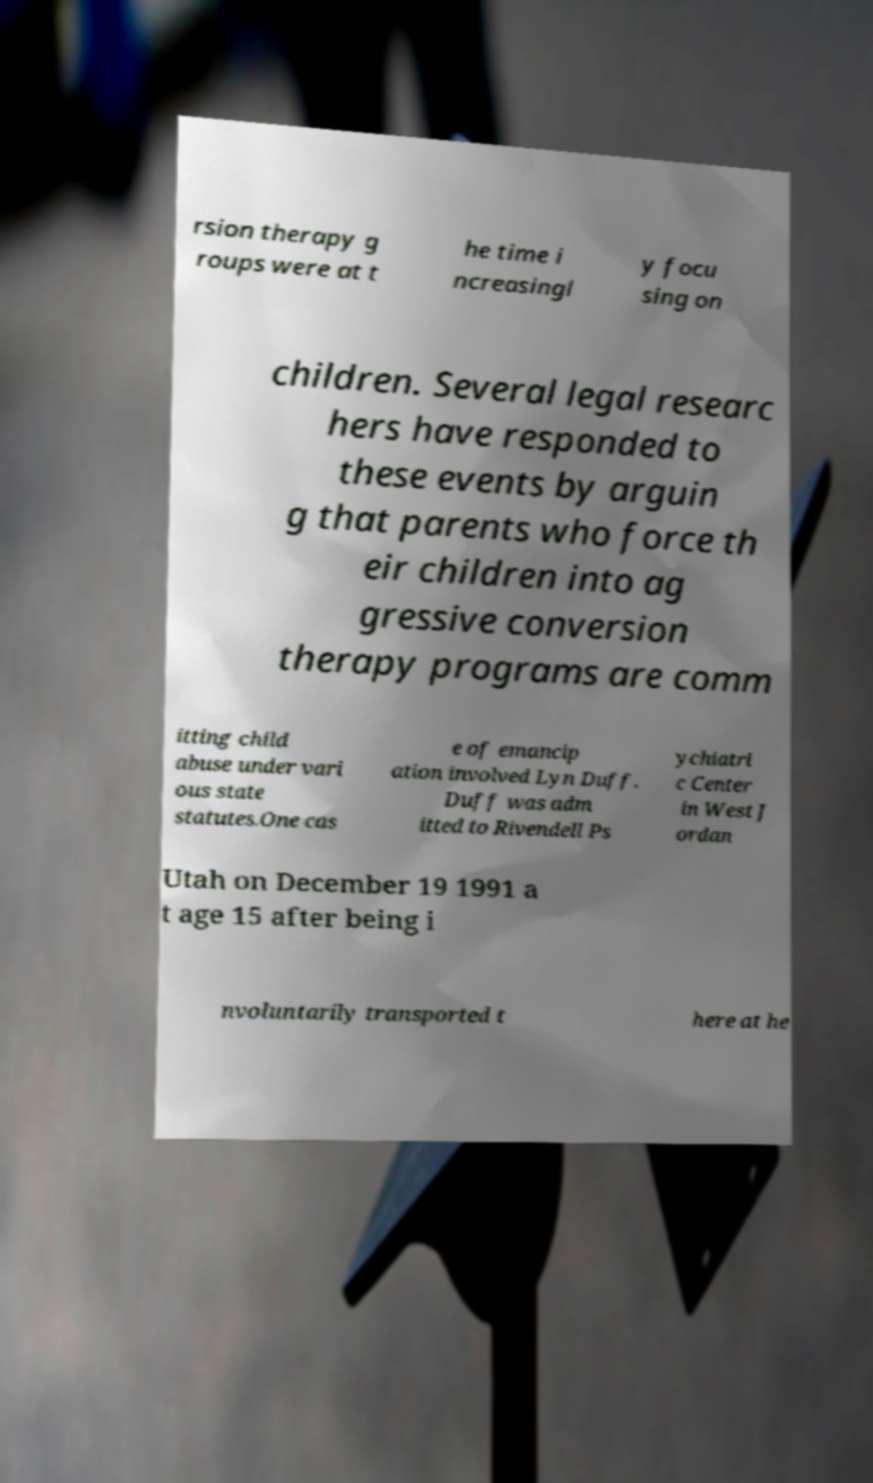For documentation purposes, I need the text within this image transcribed. Could you provide that? rsion therapy g roups were at t he time i ncreasingl y focu sing on children. Several legal researc hers have responded to these events by arguin g that parents who force th eir children into ag gressive conversion therapy programs are comm itting child abuse under vari ous state statutes.One cas e of emancip ation involved Lyn Duff. Duff was adm itted to Rivendell Ps ychiatri c Center in West J ordan Utah on December 19 1991 a t age 15 after being i nvoluntarily transported t here at he 